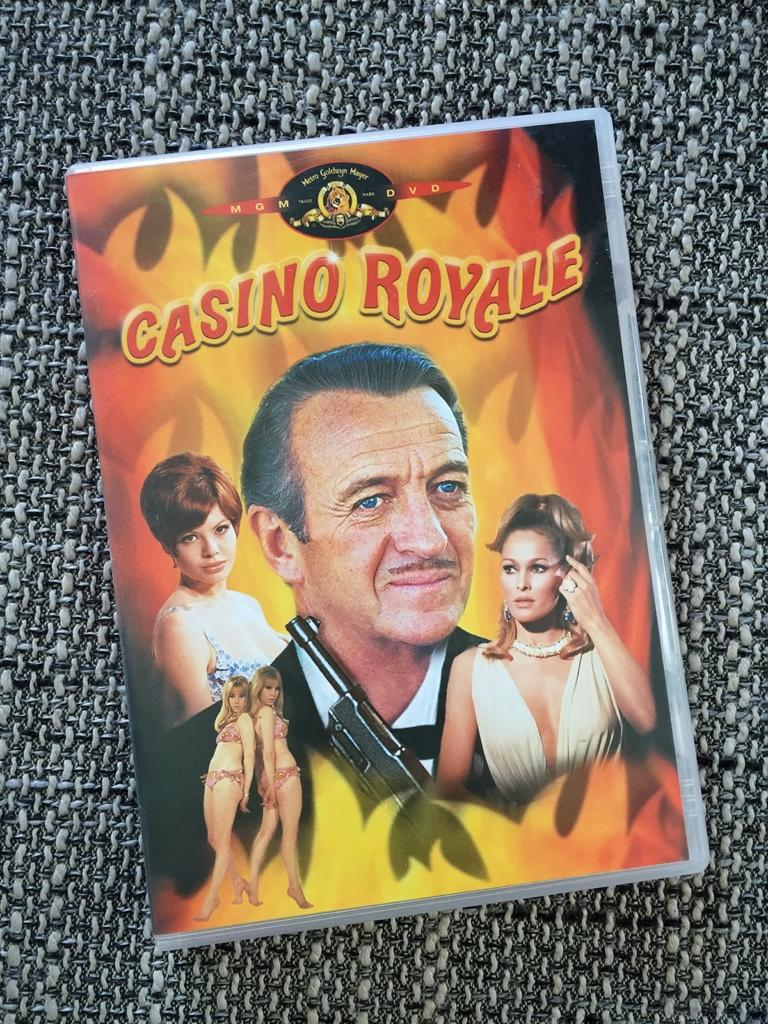What type of visual is the image? The image is a poster. Who is depicted in the poster? There is a man in the poster. What else can be seen in the poster besides the man? There are pictures of beautiful women in the poster. What color is the bee flying around the man in the poster? There is no bee present in the poster; it only features a man and pictures of beautiful women. 